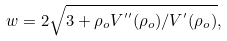Convert formula to latex. <formula><loc_0><loc_0><loc_500><loc_500>w = 2 \sqrt { 3 + \rho _ { o } V ^ { ^ { \prime \prime } } ( \rho _ { o } ) / V ^ { ^ { \prime } } ( \rho _ { o } ) } ,</formula> 